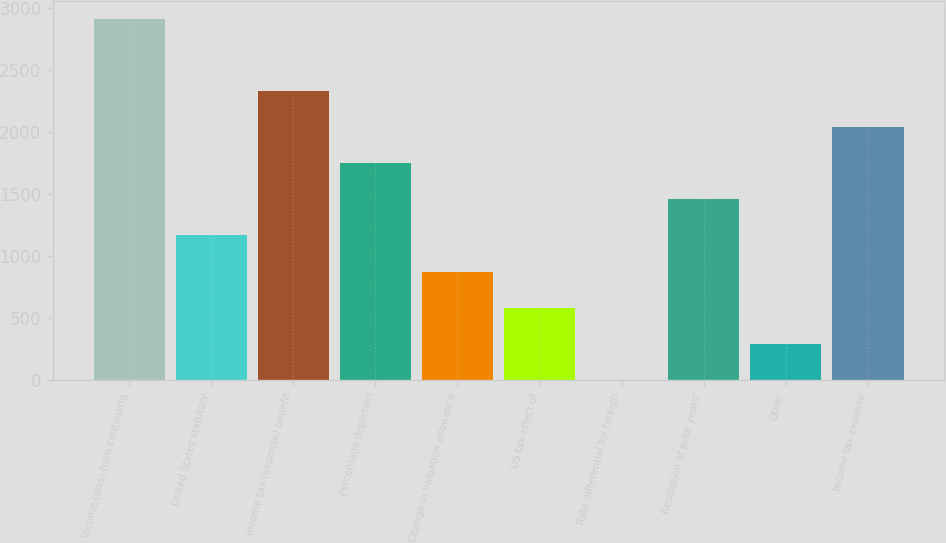Convert chart to OTSL. <chart><loc_0><loc_0><loc_500><loc_500><bar_chart><fcel>Income (loss) from continuing<fcel>United States statutory<fcel>Income tax (expense) benefit<fcel>Percentage depletion<fcel>Change in valuation allowance<fcel>US tax effect of<fcel>Rate differential for foreign<fcel>Resolution of prior years'<fcel>Other<fcel>Income tax expense<nl><fcel>2913<fcel>1167.6<fcel>2331.2<fcel>1749.4<fcel>876.7<fcel>585.8<fcel>4<fcel>1458.5<fcel>294.9<fcel>2040.3<nl></chart> 